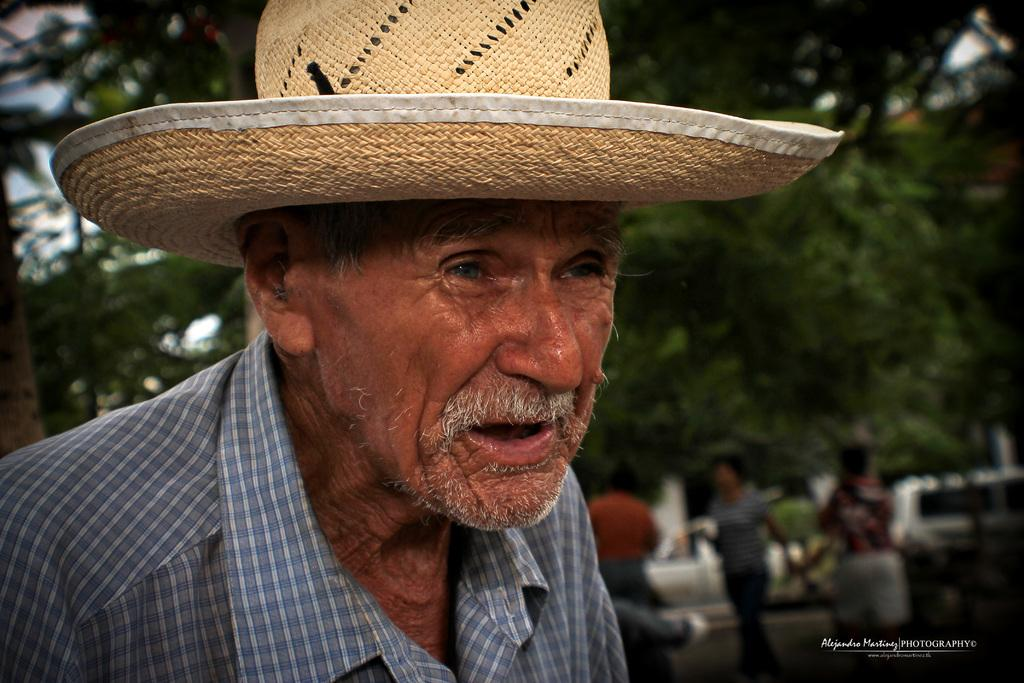What is the main subject in the foreground of the picture? There is an old man in the foreground of the picture. What is the old man wearing on his head? The old man is wearing a hat. Can you describe the background of the image? The background of the image is blurred. What can be seen in the background of the image? There are people, cars, and trees in the background of the image. What type of dirt can be seen flowing in the river in the image? There is no river present in the image, so it is not possible to determine if dirt is flowing in it. 